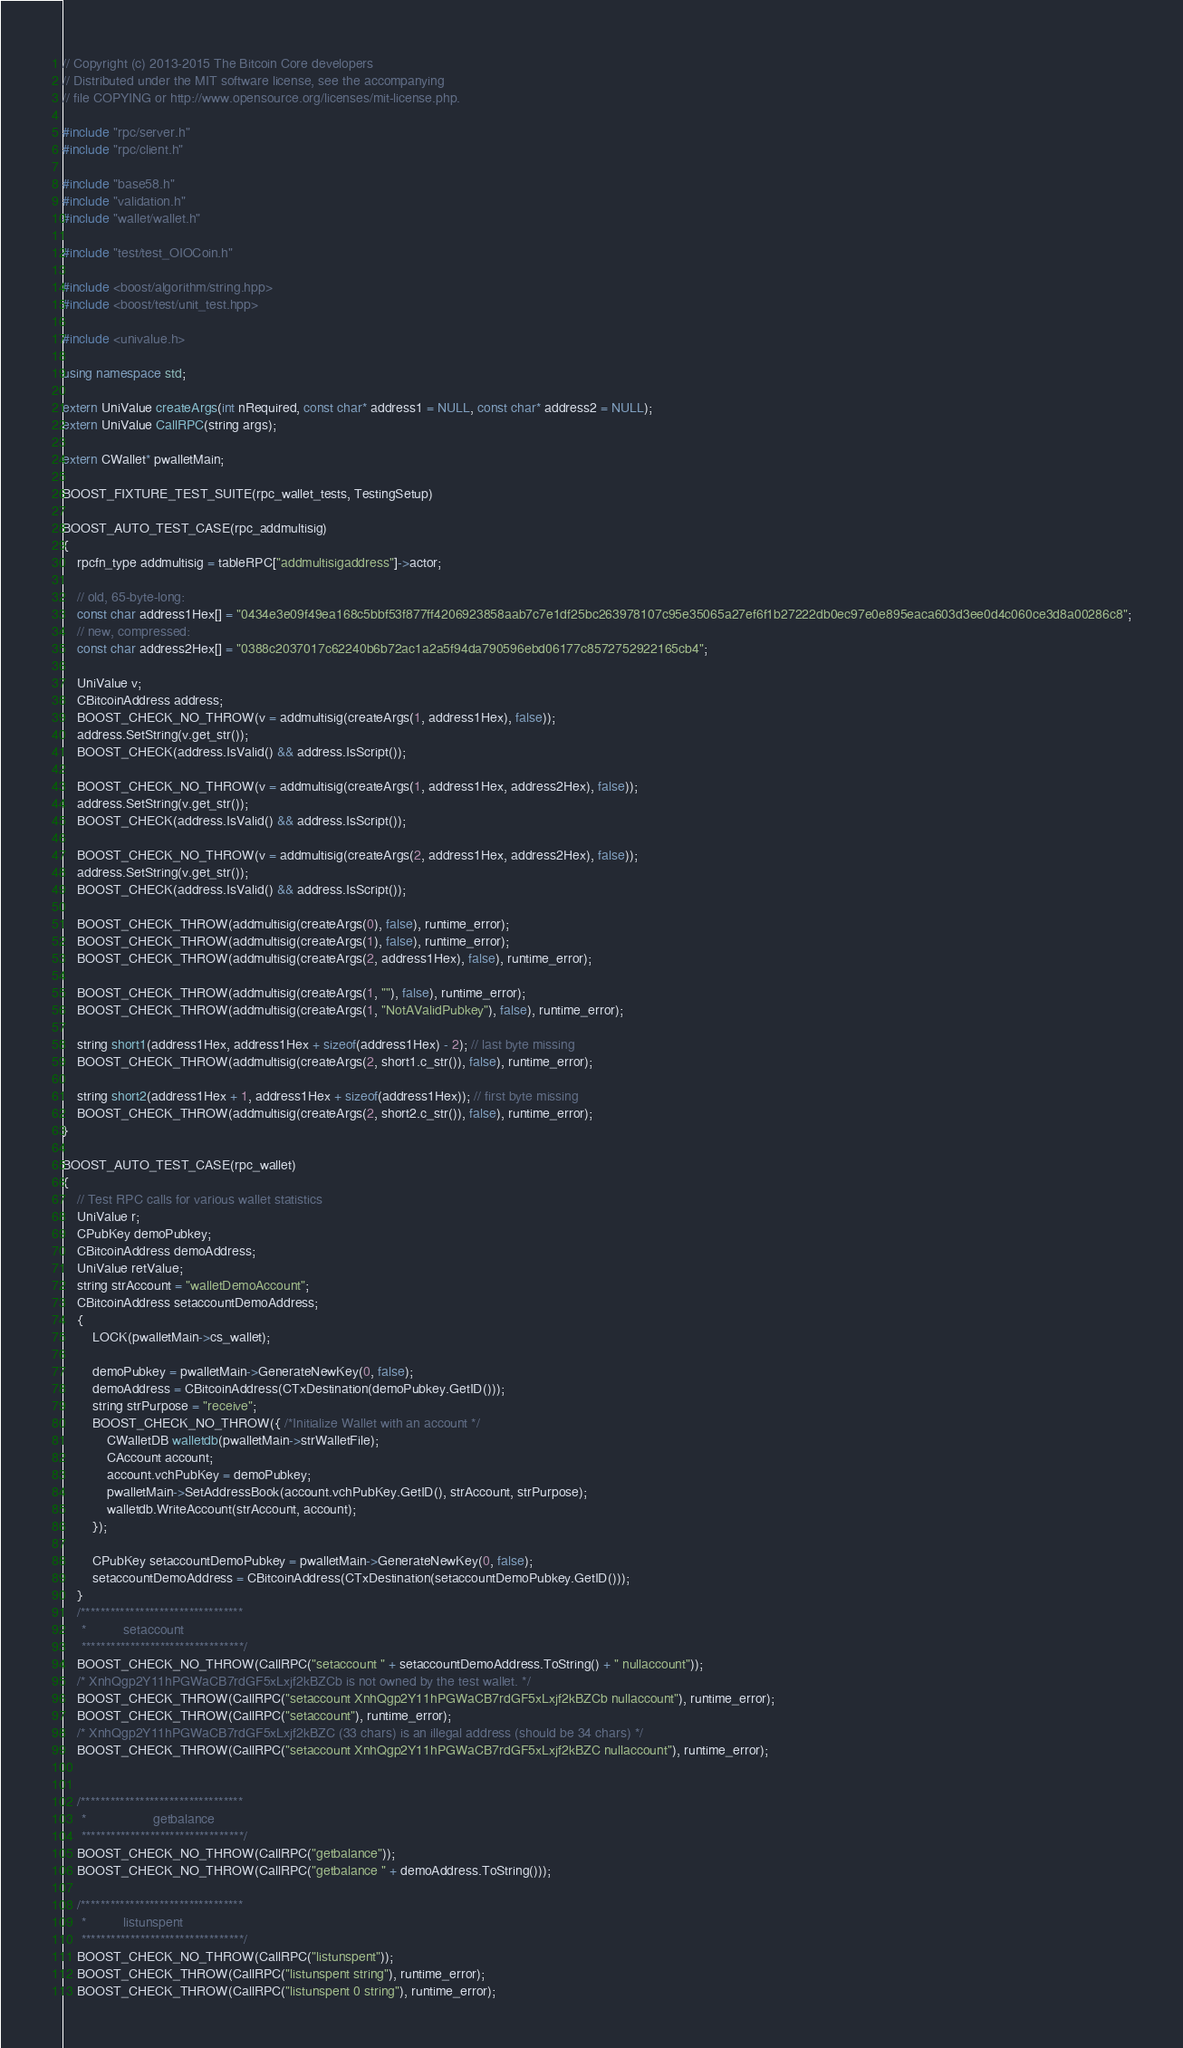Convert code to text. <code><loc_0><loc_0><loc_500><loc_500><_C++_>// Copyright (c) 2013-2015 The Bitcoin Core developers
// Distributed under the MIT software license, see the accompanying
// file COPYING or http://www.opensource.org/licenses/mit-license.php.

#include "rpc/server.h"
#include "rpc/client.h"

#include "base58.h"
#include "validation.h"
#include "wallet/wallet.h"

#include "test/test_OIOCoin.h"

#include <boost/algorithm/string.hpp>
#include <boost/test/unit_test.hpp>

#include <univalue.h>

using namespace std;

extern UniValue createArgs(int nRequired, const char* address1 = NULL, const char* address2 = NULL);
extern UniValue CallRPC(string args);

extern CWallet* pwalletMain;

BOOST_FIXTURE_TEST_SUITE(rpc_wallet_tests, TestingSetup)

BOOST_AUTO_TEST_CASE(rpc_addmultisig)
{
    rpcfn_type addmultisig = tableRPC["addmultisigaddress"]->actor;

    // old, 65-byte-long:
    const char address1Hex[] = "0434e3e09f49ea168c5bbf53f877ff4206923858aab7c7e1df25bc263978107c95e35065a27ef6f1b27222db0ec97e0e895eaca603d3ee0d4c060ce3d8a00286c8";
    // new, compressed:
    const char address2Hex[] = "0388c2037017c62240b6b72ac1a2a5f94da790596ebd06177c8572752922165cb4";

    UniValue v;
    CBitcoinAddress address;
    BOOST_CHECK_NO_THROW(v = addmultisig(createArgs(1, address1Hex), false));
    address.SetString(v.get_str());
    BOOST_CHECK(address.IsValid() && address.IsScript());

    BOOST_CHECK_NO_THROW(v = addmultisig(createArgs(1, address1Hex, address2Hex), false));
    address.SetString(v.get_str());
    BOOST_CHECK(address.IsValid() && address.IsScript());

    BOOST_CHECK_NO_THROW(v = addmultisig(createArgs(2, address1Hex, address2Hex), false));
    address.SetString(v.get_str());
    BOOST_CHECK(address.IsValid() && address.IsScript());

    BOOST_CHECK_THROW(addmultisig(createArgs(0), false), runtime_error);
    BOOST_CHECK_THROW(addmultisig(createArgs(1), false), runtime_error);
    BOOST_CHECK_THROW(addmultisig(createArgs(2, address1Hex), false), runtime_error);

    BOOST_CHECK_THROW(addmultisig(createArgs(1, ""), false), runtime_error);
    BOOST_CHECK_THROW(addmultisig(createArgs(1, "NotAValidPubkey"), false), runtime_error);

    string short1(address1Hex, address1Hex + sizeof(address1Hex) - 2); // last byte missing
    BOOST_CHECK_THROW(addmultisig(createArgs(2, short1.c_str()), false), runtime_error);

    string short2(address1Hex + 1, address1Hex + sizeof(address1Hex)); // first byte missing
    BOOST_CHECK_THROW(addmultisig(createArgs(2, short2.c_str()), false), runtime_error);
}

BOOST_AUTO_TEST_CASE(rpc_wallet)
{
    // Test RPC calls for various wallet statistics
    UniValue r;
    CPubKey demoPubkey;
    CBitcoinAddress demoAddress;
    UniValue retValue;
    string strAccount = "walletDemoAccount";
    CBitcoinAddress setaccountDemoAddress;
    {
        LOCK(pwalletMain->cs_wallet);

        demoPubkey = pwalletMain->GenerateNewKey(0, false);
        demoAddress = CBitcoinAddress(CTxDestination(demoPubkey.GetID()));
        string strPurpose = "receive";
        BOOST_CHECK_NO_THROW({ /*Initialize Wallet with an account */
            CWalletDB walletdb(pwalletMain->strWalletFile);
            CAccount account;
            account.vchPubKey = demoPubkey;
            pwalletMain->SetAddressBook(account.vchPubKey.GetID(), strAccount, strPurpose);
            walletdb.WriteAccount(strAccount, account);
        });

        CPubKey setaccountDemoPubkey = pwalletMain->GenerateNewKey(0, false);
        setaccountDemoAddress = CBitcoinAddress(CTxDestination(setaccountDemoPubkey.GetID()));
    }
    /*********************************
     * 			setaccount
     *********************************/
    BOOST_CHECK_NO_THROW(CallRPC("setaccount " + setaccountDemoAddress.ToString() + " nullaccount"));
    /* XnhQgp2Y11hPGWaCB7rdGF5xLxjf2kBZCb is not owned by the test wallet. */
    BOOST_CHECK_THROW(CallRPC("setaccount XnhQgp2Y11hPGWaCB7rdGF5xLxjf2kBZCb nullaccount"), runtime_error);
    BOOST_CHECK_THROW(CallRPC("setaccount"), runtime_error);
    /* XnhQgp2Y11hPGWaCB7rdGF5xLxjf2kBZC (33 chars) is an illegal address (should be 34 chars) */
    BOOST_CHECK_THROW(CallRPC("setaccount XnhQgp2Y11hPGWaCB7rdGF5xLxjf2kBZC nullaccount"), runtime_error);


    /*********************************
     *                  getbalance
     *********************************/
    BOOST_CHECK_NO_THROW(CallRPC("getbalance"));
    BOOST_CHECK_NO_THROW(CallRPC("getbalance " + demoAddress.ToString()));

    /*********************************
     * 			listunspent
     *********************************/
    BOOST_CHECK_NO_THROW(CallRPC("listunspent"));
    BOOST_CHECK_THROW(CallRPC("listunspent string"), runtime_error);
    BOOST_CHECK_THROW(CallRPC("listunspent 0 string"), runtime_error);</code> 